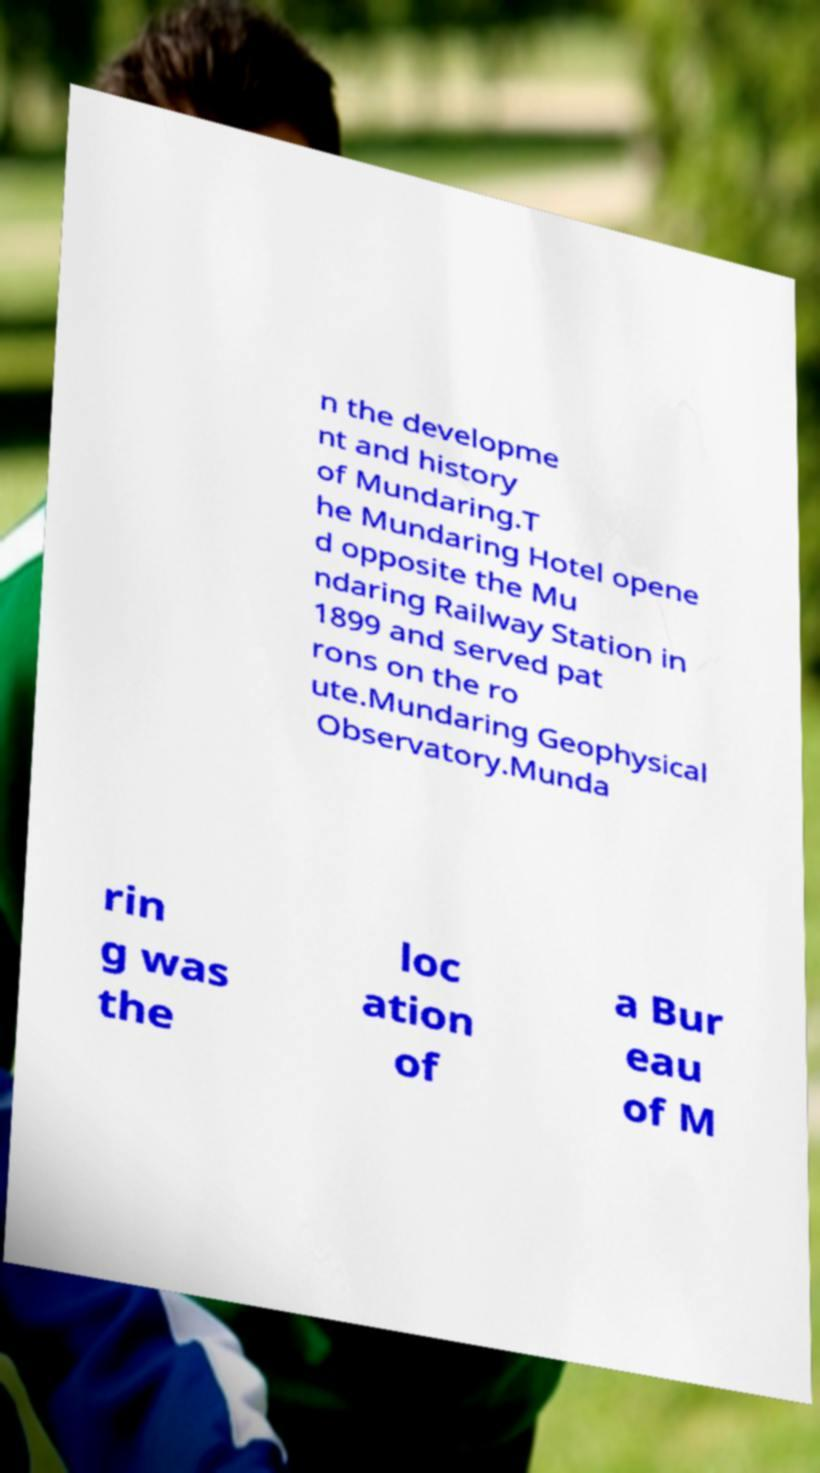There's text embedded in this image that I need extracted. Can you transcribe it verbatim? n the developme nt and history of Mundaring.T he Mundaring Hotel opene d opposite the Mu ndaring Railway Station in 1899 and served pat rons on the ro ute.Mundaring Geophysical Observatory.Munda rin g was the loc ation of a Bur eau of M 